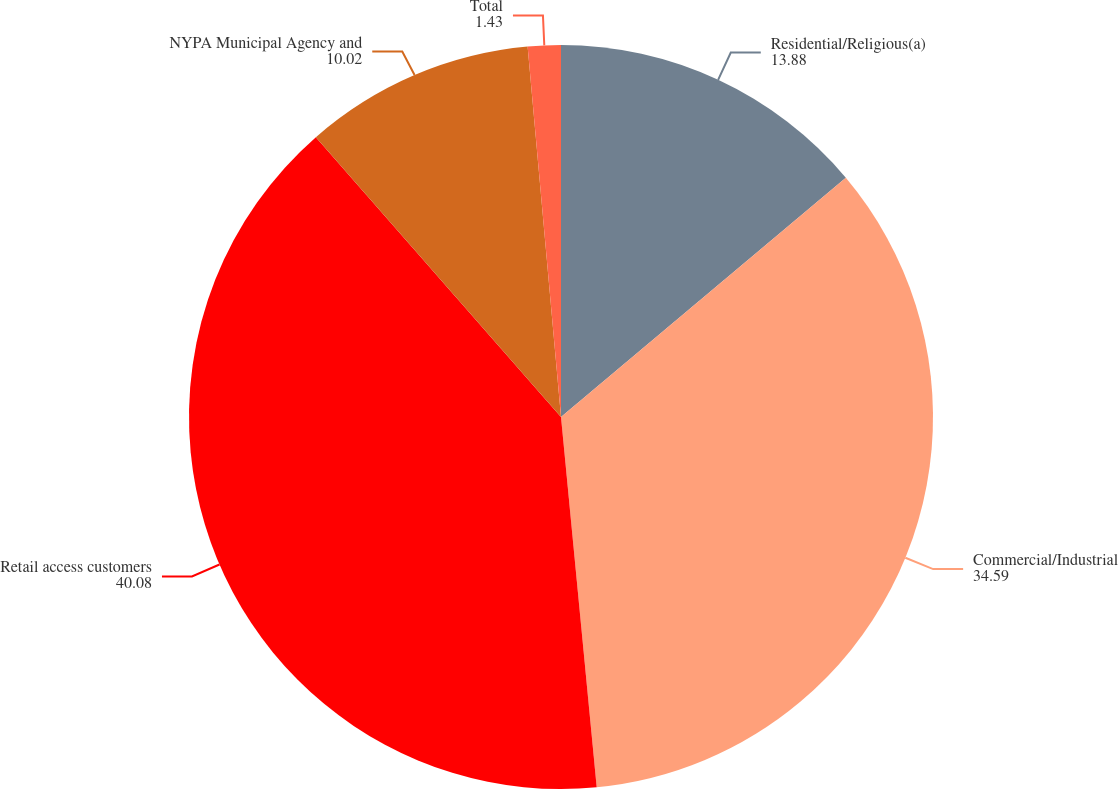Convert chart. <chart><loc_0><loc_0><loc_500><loc_500><pie_chart><fcel>Residential/Religious(a)<fcel>Commercial/Industrial<fcel>Retail access customers<fcel>NYPA Municipal Agency and<fcel>Total<nl><fcel>13.88%<fcel>34.59%<fcel>40.08%<fcel>10.02%<fcel>1.43%<nl></chart> 